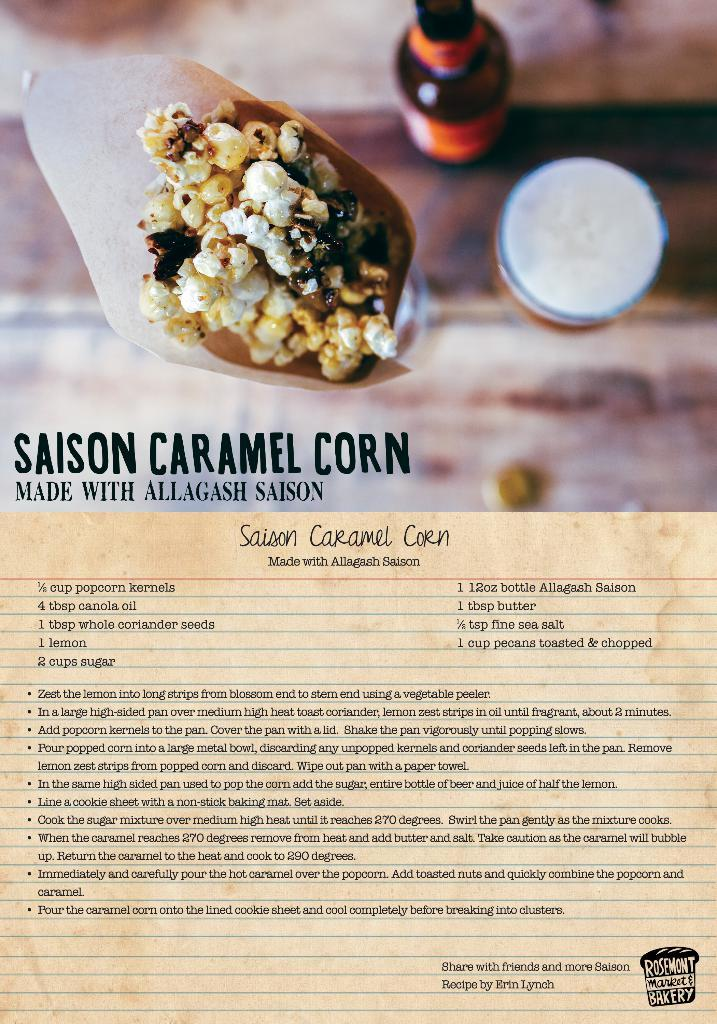<image>
Present a compact description of the photo's key features. Instructions to make Saison Caramel Corn made with allagash saison. 